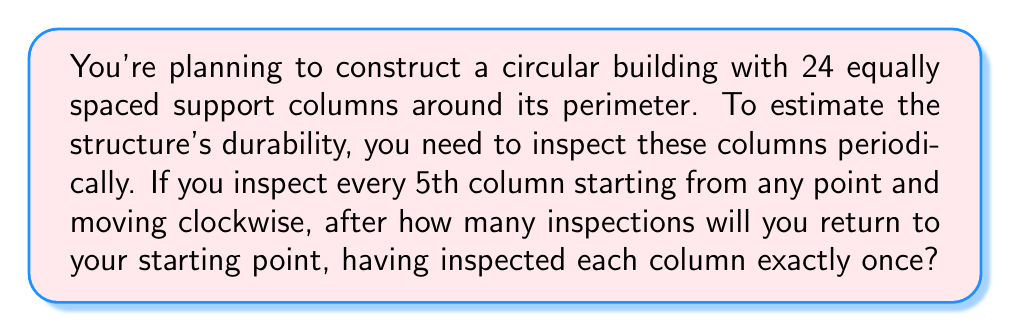Solve this math problem. Let's approach this problem using modular arithmetic:

1) We have 24 columns, numbered 0 to 23.

2) We're inspecting every 5th column, which means we're adding 5 (mod 24) each time.

3) Let's start at column 0 and see the sequence of inspections:
   $0 \rightarrow 5 \rightarrow 10 \rightarrow 15 \rightarrow 20 \rightarrow 1 \rightarrow 6 \rightarrow 11 \rightarrow 16 \rightarrow 21 \rightarrow 2 \rightarrow ...$

4) We can represent this mathematically as:
   $5k \pmod{24}$, where $k$ is the number of inspections.

5) We want to find the smallest positive $k$ such that $5k \equiv 0 \pmod{24}$.

6) This is equivalent to solving the congruence:
   $5k \equiv 0 \pmod{24}$

7) We can simplify this:
   $5k = 24m$ for some integer $m$

8) The least common multiple of 5 and 24 will give us the smallest $k$:
   $\text{lcm}(5,24) = \frac{5 \cdot 24}{\gcd(5,24)} = \frac{120}{1} = 120$

9) So, $k = 120/5 = 24$

10) We can verify:
    $24 \cdot 5 = 120 \equiv 0 \pmod{24}$

Therefore, it will take 24 inspections to return to the starting point, having inspected each column exactly once.

This also makes sense intuitively: since there are 24 columns and we're inspecting every 5th one, we need to inspect 24 times to cover all columns.
Answer: 24 inspections 